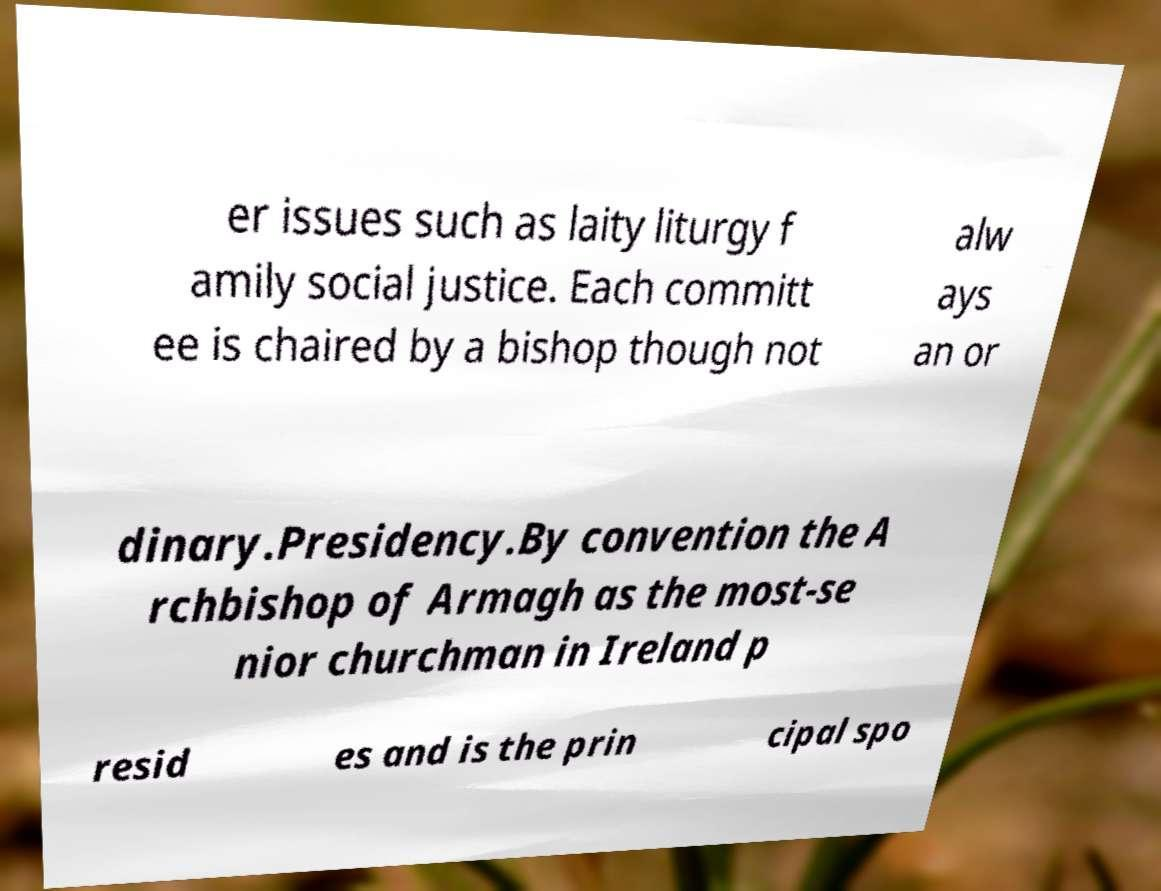Could you extract and type out the text from this image? er issues such as laity liturgy f amily social justice. Each committ ee is chaired by a bishop though not alw ays an or dinary.Presidency.By convention the A rchbishop of Armagh as the most-se nior churchman in Ireland p resid es and is the prin cipal spo 